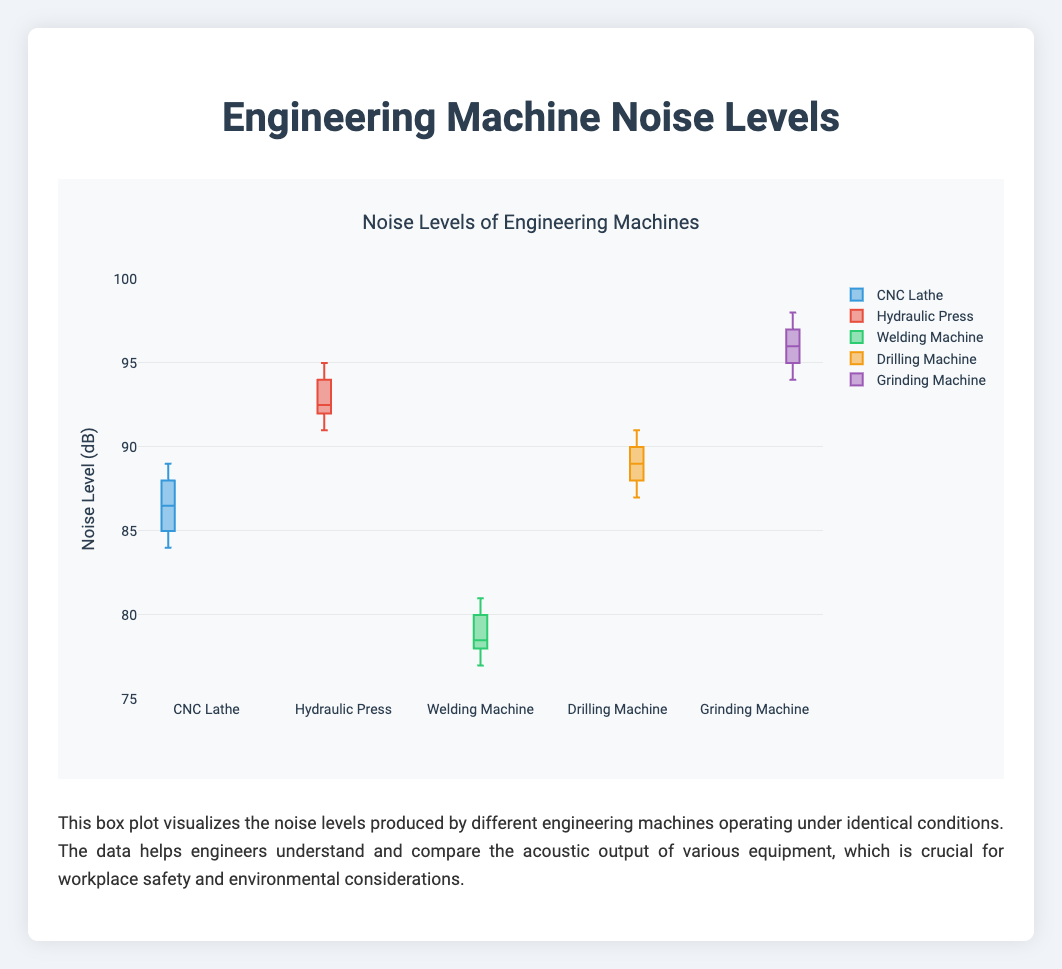What is the highest noise level recorded by the Grinding Machine? To determine the highest noise level recorded by the Grinding Machine, look at the top whisker or data points. The highest value recorded is 98 dB.
Answer: 98 dB Which machine has the lowest median noise level? Compare the median lines (usually the line inside the box) of all machines. The Welding Machine has the lowest median value around 78-79 dB.
Answer: Welding Machine How do the interquartile ranges (IQRs) of the CNC Lathe and Drilling Machine compare? The IQR is the difference between the upper quartile (Q3) and the lower quartile (Q1). The CNC Lathe has a tighter IQR around 86 to 88, while the Drilling Machine’s IQR ranges more broadly from 88 to 90. The Drilling Machine's IQR is wider than the CNC Lathe's.
Answer: Drilling Machine’s IQR is wider Which machine exhibits the most consistent noise levels, judging by the spread of the box plot? Look at the width of the boxes; smaller boxes indicate less variation. The CNC Lathe shows the most consistency with less spread in its box.
Answer: CNC Lathe Is there any machine that has outliers in its noise levels? Outliers are marked as individual points outside the whiskers. No machine has data points outside the whiskers, thus no outliers.
Answer: No Which machine has the highest median noise level? The median is represented by the line inside the box. The Grinding Machine has the highest median, appearing around 96 dB.
Answer: Grinding Machine Compare the median noise levels of the Hydraulic Press and the Drilling Machine. Which one is higher? The median of each machine is the line inside the box. The Hydraulic Press has a median around 93 dB, higher than the Drilling Machine’s median of around 89 dB.
Answer: Hydraulic Press Between the Welding Machine and the CNC Lathe, which one has a lower maximum noise level? Look at the top end of the whiskers or data points. The maximum for the Welding Machine is 81 dB, while the CNC Lathe is 89 dB. The Welding Machine has a lower maximum noise level.
Answer: Welding Machine How many machines have noise levels that can reach 90 dB or above? Check the maximum values (top whisker or points) for each machine. The Hydraulic Press, Drilling Machine, and Grinding Machine have maximum levels of 90 dB or above.
Answer: Three machines What is the range of the noise levels for the Hydraulic Press? The range is the difference between the maximum and minimum values. For the Hydraulic Press, the maximum is 95 dB and the minimum is 91 dB, so the range is 4 dB.
Answer: 4 dB 